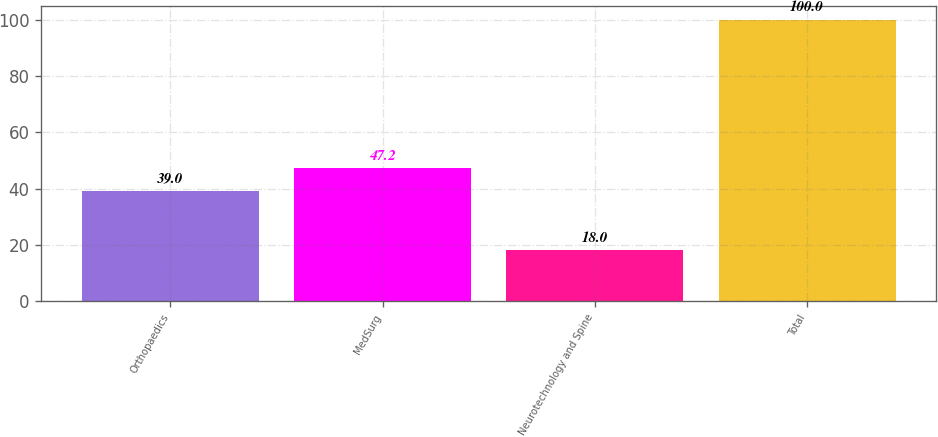Convert chart. <chart><loc_0><loc_0><loc_500><loc_500><bar_chart><fcel>Orthopaedics<fcel>MedSurg<fcel>Neurotechnology and Spine<fcel>Total<nl><fcel>39<fcel>47.2<fcel>18<fcel>100<nl></chart> 